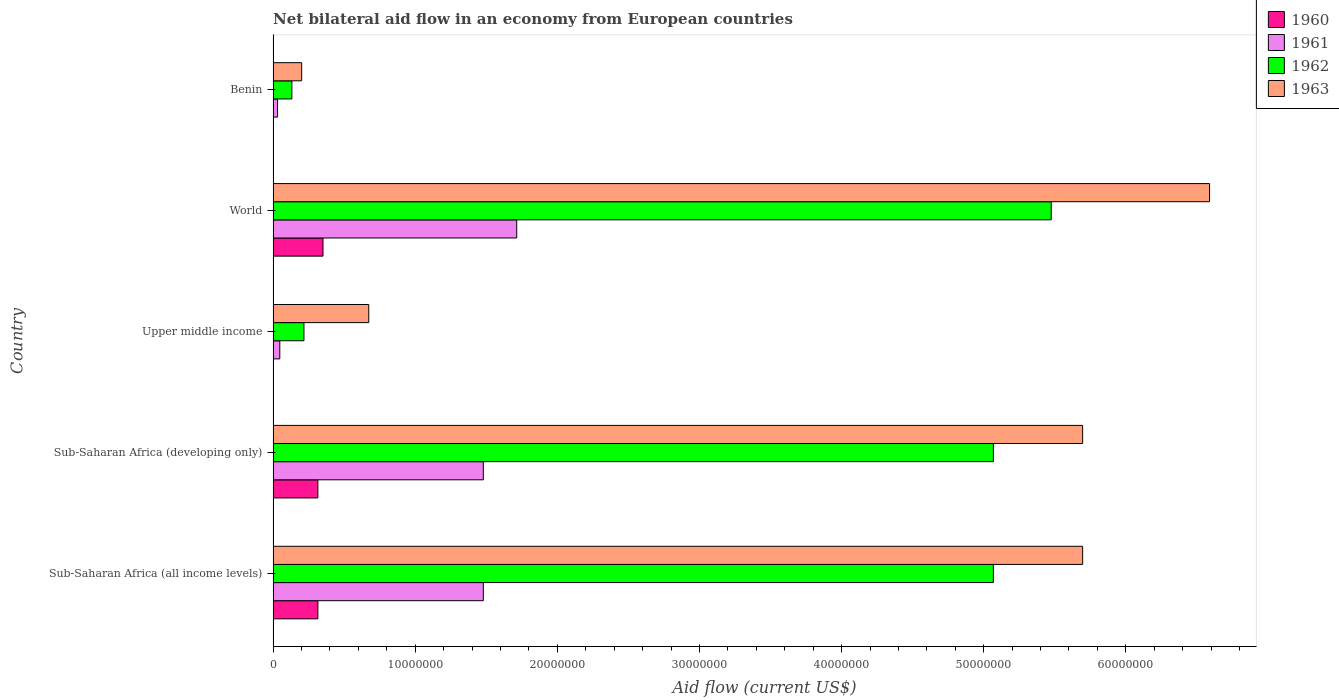How many different coloured bars are there?
Ensure brevity in your answer.  4. Are the number of bars per tick equal to the number of legend labels?
Provide a short and direct response. Yes. Are the number of bars on each tick of the Y-axis equal?
Keep it short and to the point. Yes. In how many cases, is the number of bars for a given country not equal to the number of legend labels?
Make the answer very short. 0. What is the net bilateral aid flow in 1963 in World?
Offer a terse response. 6.59e+07. Across all countries, what is the maximum net bilateral aid flow in 1961?
Your response must be concise. 1.71e+07. In which country was the net bilateral aid flow in 1960 maximum?
Offer a terse response. World. In which country was the net bilateral aid flow in 1963 minimum?
Your response must be concise. Benin. What is the total net bilateral aid flow in 1960 in the graph?
Ensure brevity in your answer.  9.83e+06. What is the difference between the net bilateral aid flow in 1961 in Sub-Saharan Africa (all income levels) and that in World?
Your answer should be compact. -2.35e+06. What is the difference between the net bilateral aid flow in 1961 in Sub-Saharan Africa (developing only) and the net bilateral aid flow in 1962 in World?
Make the answer very short. -4.00e+07. What is the average net bilateral aid flow in 1960 per country?
Offer a terse response. 1.97e+06. What is the difference between the net bilateral aid flow in 1963 and net bilateral aid flow in 1960 in Sub-Saharan Africa (all income levels)?
Give a very brief answer. 5.38e+07. In how many countries, is the net bilateral aid flow in 1960 greater than 44000000 US$?
Offer a very short reply. 0. What is the ratio of the net bilateral aid flow in 1962 in Upper middle income to that in World?
Keep it short and to the point. 0.04. Is the net bilateral aid flow in 1962 in Upper middle income less than that in World?
Make the answer very short. Yes. What is the difference between the highest and the second highest net bilateral aid flow in 1961?
Provide a succinct answer. 2.35e+06. What is the difference between the highest and the lowest net bilateral aid flow in 1961?
Keep it short and to the point. 1.68e+07. Is the sum of the net bilateral aid flow in 1962 in Sub-Saharan Africa (all income levels) and Upper middle income greater than the maximum net bilateral aid flow in 1960 across all countries?
Offer a terse response. Yes. Is it the case that in every country, the sum of the net bilateral aid flow in 1962 and net bilateral aid flow in 1963 is greater than the sum of net bilateral aid flow in 1960 and net bilateral aid flow in 1961?
Offer a terse response. No. What does the 1st bar from the top in Sub-Saharan Africa (all income levels) represents?
Give a very brief answer. 1963. Is it the case that in every country, the sum of the net bilateral aid flow in 1961 and net bilateral aid flow in 1962 is greater than the net bilateral aid flow in 1960?
Provide a succinct answer. Yes. Are all the bars in the graph horizontal?
Give a very brief answer. Yes. Are the values on the major ticks of X-axis written in scientific E-notation?
Offer a terse response. No. Does the graph contain grids?
Your answer should be very brief. No. How many legend labels are there?
Provide a succinct answer. 4. What is the title of the graph?
Provide a short and direct response. Net bilateral aid flow in an economy from European countries. Does "1997" appear as one of the legend labels in the graph?
Your response must be concise. No. What is the Aid flow (current US$) of 1960 in Sub-Saharan Africa (all income levels)?
Your response must be concise. 3.15e+06. What is the Aid flow (current US$) of 1961 in Sub-Saharan Africa (all income levels)?
Offer a very short reply. 1.48e+07. What is the Aid flow (current US$) of 1962 in Sub-Saharan Africa (all income levels)?
Provide a succinct answer. 5.07e+07. What is the Aid flow (current US$) of 1963 in Sub-Saharan Africa (all income levels)?
Your answer should be very brief. 5.70e+07. What is the Aid flow (current US$) of 1960 in Sub-Saharan Africa (developing only)?
Your answer should be compact. 3.15e+06. What is the Aid flow (current US$) in 1961 in Sub-Saharan Africa (developing only)?
Offer a terse response. 1.48e+07. What is the Aid flow (current US$) of 1962 in Sub-Saharan Africa (developing only)?
Give a very brief answer. 5.07e+07. What is the Aid flow (current US$) in 1963 in Sub-Saharan Africa (developing only)?
Provide a succinct answer. 5.70e+07. What is the Aid flow (current US$) in 1960 in Upper middle income?
Offer a very short reply. 10000. What is the Aid flow (current US$) of 1962 in Upper middle income?
Your answer should be very brief. 2.17e+06. What is the Aid flow (current US$) in 1963 in Upper middle income?
Offer a very short reply. 6.73e+06. What is the Aid flow (current US$) in 1960 in World?
Give a very brief answer. 3.51e+06. What is the Aid flow (current US$) of 1961 in World?
Provide a succinct answer. 1.71e+07. What is the Aid flow (current US$) of 1962 in World?
Give a very brief answer. 5.48e+07. What is the Aid flow (current US$) in 1963 in World?
Offer a terse response. 6.59e+07. What is the Aid flow (current US$) in 1962 in Benin?
Make the answer very short. 1.32e+06. What is the Aid flow (current US$) of 1963 in Benin?
Ensure brevity in your answer.  2.01e+06. Across all countries, what is the maximum Aid flow (current US$) of 1960?
Give a very brief answer. 3.51e+06. Across all countries, what is the maximum Aid flow (current US$) of 1961?
Your answer should be compact. 1.71e+07. Across all countries, what is the maximum Aid flow (current US$) of 1962?
Keep it short and to the point. 5.48e+07. Across all countries, what is the maximum Aid flow (current US$) in 1963?
Give a very brief answer. 6.59e+07. Across all countries, what is the minimum Aid flow (current US$) in 1962?
Your answer should be compact. 1.32e+06. Across all countries, what is the minimum Aid flow (current US$) in 1963?
Your response must be concise. 2.01e+06. What is the total Aid flow (current US$) of 1960 in the graph?
Your response must be concise. 9.83e+06. What is the total Aid flow (current US$) in 1961 in the graph?
Offer a terse response. 4.75e+07. What is the total Aid flow (current US$) of 1962 in the graph?
Give a very brief answer. 1.60e+08. What is the total Aid flow (current US$) of 1963 in the graph?
Ensure brevity in your answer.  1.89e+08. What is the difference between the Aid flow (current US$) of 1960 in Sub-Saharan Africa (all income levels) and that in Sub-Saharan Africa (developing only)?
Make the answer very short. 0. What is the difference between the Aid flow (current US$) of 1961 in Sub-Saharan Africa (all income levels) and that in Sub-Saharan Africa (developing only)?
Provide a succinct answer. 0. What is the difference between the Aid flow (current US$) in 1962 in Sub-Saharan Africa (all income levels) and that in Sub-Saharan Africa (developing only)?
Provide a short and direct response. 0. What is the difference between the Aid flow (current US$) of 1963 in Sub-Saharan Africa (all income levels) and that in Sub-Saharan Africa (developing only)?
Offer a very short reply. 0. What is the difference between the Aid flow (current US$) of 1960 in Sub-Saharan Africa (all income levels) and that in Upper middle income?
Offer a terse response. 3.14e+06. What is the difference between the Aid flow (current US$) in 1961 in Sub-Saharan Africa (all income levels) and that in Upper middle income?
Provide a short and direct response. 1.43e+07. What is the difference between the Aid flow (current US$) of 1962 in Sub-Saharan Africa (all income levels) and that in Upper middle income?
Provide a short and direct response. 4.85e+07. What is the difference between the Aid flow (current US$) of 1963 in Sub-Saharan Africa (all income levels) and that in Upper middle income?
Provide a succinct answer. 5.02e+07. What is the difference between the Aid flow (current US$) in 1960 in Sub-Saharan Africa (all income levels) and that in World?
Make the answer very short. -3.60e+05. What is the difference between the Aid flow (current US$) of 1961 in Sub-Saharan Africa (all income levels) and that in World?
Provide a short and direct response. -2.35e+06. What is the difference between the Aid flow (current US$) in 1962 in Sub-Saharan Africa (all income levels) and that in World?
Offer a very short reply. -4.07e+06. What is the difference between the Aid flow (current US$) in 1963 in Sub-Saharan Africa (all income levels) and that in World?
Give a very brief answer. -8.93e+06. What is the difference between the Aid flow (current US$) of 1960 in Sub-Saharan Africa (all income levels) and that in Benin?
Your answer should be very brief. 3.14e+06. What is the difference between the Aid flow (current US$) in 1961 in Sub-Saharan Africa (all income levels) and that in Benin?
Keep it short and to the point. 1.45e+07. What is the difference between the Aid flow (current US$) of 1962 in Sub-Saharan Africa (all income levels) and that in Benin?
Give a very brief answer. 4.94e+07. What is the difference between the Aid flow (current US$) of 1963 in Sub-Saharan Africa (all income levels) and that in Benin?
Offer a very short reply. 5.50e+07. What is the difference between the Aid flow (current US$) of 1960 in Sub-Saharan Africa (developing only) and that in Upper middle income?
Make the answer very short. 3.14e+06. What is the difference between the Aid flow (current US$) of 1961 in Sub-Saharan Africa (developing only) and that in Upper middle income?
Give a very brief answer. 1.43e+07. What is the difference between the Aid flow (current US$) of 1962 in Sub-Saharan Africa (developing only) and that in Upper middle income?
Offer a very short reply. 4.85e+07. What is the difference between the Aid flow (current US$) of 1963 in Sub-Saharan Africa (developing only) and that in Upper middle income?
Provide a succinct answer. 5.02e+07. What is the difference between the Aid flow (current US$) of 1960 in Sub-Saharan Africa (developing only) and that in World?
Your answer should be compact. -3.60e+05. What is the difference between the Aid flow (current US$) of 1961 in Sub-Saharan Africa (developing only) and that in World?
Give a very brief answer. -2.35e+06. What is the difference between the Aid flow (current US$) of 1962 in Sub-Saharan Africa (developing only) and that in World?
Your response must be concise. -4.07e+06. What is the difference between the Aid flow (current US$) of 1963 in Sub-Saharan Africa (developing only) and that in World?
Ensure brevity in your answer.  -8.93e+06. What is the difference between the Aid flow (current US$) of 1960 in Sub-Saharan Africa (developing only) and that in Benin?
Your answer should be compact. 3.14e+06. What is the difference between the Aid flow (current US$) of 1961 in Sub-Saharan Africa (developing only) and that in Benin?
Give a very brief answer. 1.45e+07. What is the difference between the Aid flow (current US$) of 1962 in Sub-Saharan Africa (developing only) and that in Benin?
Provide a short and direct response. 4.94e+07. What is the difference between the Aid flow (current US$) of 1963 in Sub-Saharan Africa (developing only) and that in Benin?
Provide a short and direct response. 5.50e+07. What is the difference between the Aid flow (current US$) of 1960 in Upper middle income and that in World?
Your answer should be compact. -3.50e+06. What is the difference between the Aid flow (current US$) of 1961 in Upper middle income and that in World?
Keep it short and to the point. -1.67e+07. What is the difference between the Aid flow (current US$) of 1962 in Upper middle income and that in World?
Ensure brevity in your answer.  -5.26e+07. What is the difference between the Aid flow (current US$) in 1963 in Upper middle income and that in World?
Ensure brevity in your answer.  -5.92e+07. What is the difference between the Aid flow (current US$) in 1960 in Upper middle income and that in Benin?
Keep it short and to the point. 0. What is the difference between the Aid flow (current US$) in 1961 in Upper middle income and that in Benin?
Offer a very short reply. 1.60e+05. What is the difference between the Aid flow (current US$) of 1962 in Upper middle income and that in Benin?
Keep it short and to the point. 8.50e+05. What is the difference between the Aid flow (current US$) of 1963 in Upper middle income and that in Benin?
Provide a short and direct response. 4.72e+06. What is the difference between the Aid flow (current US$) of 1960 in World and that in Benin?
Your response must be concise. 3.50e+06. What is the difference between the Aid flow (current US$) of 1961 in World and that in Benin?
Offer a terse response. 1.68e+07. What is the difference between the Aid flow (current US$) of 1962 in World and that in Benin?
Make the answer very short. 5.34e+07. What is the difference between the Aid flow (current US$) of 1963 in World and that in Benin?
Your answer should be compact. 6.39e+07. What is the difference between the Aid flow (current US$) in 1960 in Sub-Saharan Africa (all income levels) and the Aid flow (current US$) in 1961 in Sub-Saharan Africa (developing only)?
Make the answer very short. -1.16e+07. What is the difference between the Aid flow (current US$) in 1960 in Sub-Saharan Africa (all income levels) and the Aid flow (current US$) in 1962 in Sub-Saharan Africa (developing only)?
Ensure brevity in your answer.  -4.75e+07. What is the difference between the Aid flow (current US$) in 1960 in Sub-Saharan Africa (all income levels) and the Aid flow (current US$) in 1963 in Sub-Saharan Africa (developing only)?
Provide a succinct answer. -5.38e+07. What is the difference between the Aid flow (current US$) of 1961 in Sub-Saharan Africa (all income levels) and the Aid flow (current US$) of 1962 in Sub-Saharan Africa (developing only)?
Ensure brevity in your answer.  -3.59e+07. What is the difference between the Aid flow (current US$) in 1961 in Sub-Saharan Africa (all income levels) and the Aid flow (current US$) in 1963 in Sub-Saharan Africa (developing only)?
Offer a very short reply. -4.22e+07. What is the difference between the Aid flow (current US$) of 1962 in Sub-Saharan Africa (all income levels) and the Aid flow (current US$) of 1963 in Sub-Saharan Africa (developing only)?
Ensure brevity in your answer.  -6.28e+06. What is the difference between the Aid flow (current US$) in 1960 in Sub-Saharan Africa (all income levels) and the Aid flow (current US$) in 1961 in Upper middle income?
Ensure brevity in your answer.  2.68e+06. What is the difference between the Aid flow (current US$) in 1960 in Sub-Saharan Africa (all income levels) and the Aid flow (current US$) in 1962 in Upper middle income?
Ensure brevity in your answer.  9.80e+05. What is the difference between the Aid flow (current US$) of 1960 in Sub-Saharan Africa (all income levels) and the Aid flow (current US$) of 1963 in Upper middle income?
Provide a succinct answer. -3.58e+06. What is the difference between the Aid flow (current US$) in 1961 in Sub-Saharan Africa (all income levels) and the Aid flow (current US$) in 1962 in Upper middle income?
Provide a succinct answer. 1.26e+07. What is the difference between the Aid flow (current US$) in 1961 in Sub-Saharan Africa (all income levels) and the Aid flow (current US$) in 1963 in Upper middle income?
Provide a succinct answer. 8.06e+06. What is the difference between the Aid flow (current US$) of 1962 in Sub-Saharan Africa (all income levels) and the Aid flow (current US$) of 1963 in Upper middle income?
Provide a short and direct response. 4.40e+07. What is the difference between the Aid flow (current US$) in 1960 in Sub-Saharan Africa (all income levels) and the Aid flow (current US$) in 1961 in World?
Provide a succinct answer. -1.40e+07. What is the difference between the Aid flow (current US$) in 1960 in Sub-Saharan Africa (all income levels) and the Aid flow (current US$) in 1962 in World?
Your answer should be compact. -5.16e+07. What is the difference between the Aid flow (current US$) in 1960 in Sub-Saharan Africa (all income levels) and the Aid flow (current US$) in 1963 in World?
Provide a short and direct response. -6.27e+07. What is the difference between the Aid flow (current US$) of 1961 in Sub-Saharan Africa (all income levels) and the Aid flow (current US$) of 1962 in World?
Provide a succinct answer. -4.00e+07. What is the difference between the Aid flow (current US$) of 1961 in Sub-Saharan Africa (all income levels) and the Aid flow (current US$) of 1963 in World?
Offer a very short reply. -5.11e+07. What is the difference between the Aid flow (current US$) in 1962 in Sub-Saharan Africa (all income levels) and the Aid flow (current US$) in 1963 in World?
Provide a short and direct response. -1.52e+07. What is the difference between the Aid flow (current US$) in 1960 in Sub-Saharan Africa (all income levels) and the Aid flow (current US$) in 1961 in Benin?
Make the answer very short. 2.84e+06. What is the difference between the Aid flow (current US$) in 1960 in Sub-Saharan Africa (all income levels) and the Aid flow (current US$) in 1962 in Benin?
Your response must be concise. 1.83e+06. What is the difference between the Aid flow (current US$) in 1960 in Sub-Saharan Africa (all income levels) and the Aid flow (current US$) in 1963 in Benin?
Ensure brevity in your answer.  1.14e+06. What is the difference between the Aid flow (current US$) of 1961 in Sub-Saharan Africa (all income levels) and the Aid flow (current US$) of 1962 in Benin?
Provide a succinct answer. 1.35e+07. What is the difference between the Aid flow (current US$) of 1961 in Sub-Saharan Africa (all income levels) and the Aid flow (current US$) of 1963 in Benin?
Provide a short and direct response. 1.28e+07. What is the difference between the Aid flow (current US$) in 1962 in Sub-Saharan Africa (all income levels) and the Aid flow (current US$) in 1963 in Benin?
Offer a very short reply. 4.87e+07. What is the difference between the Aid flow (current US$) in 1960 in Sub-Saharan Africa (developing only) and the Aid flow (current US$) in 1961 in Upper middle income?
Your answer should be compact. 2.68e+06. What is the difference between the Aid flow (current US$) of 1960 in Sub-Saharan Africa (developing only) and the Aid flow (current US$) of 1962 in Upper middle income?
Keep it short and to the point. 9.80e+05. What is the difference between the Aid flow (current US$) of 1960 in Sub-Saharan Africa (developing only) and the Aid flow (current US$) of 1963 in Upper middle income?
Offer a very short reply. -3.58e+06. What is the difference between the Aid flow (current US$) of 1961 in Sub-Saharan Africa (developing only) and the Aid flow (current US$) of 1962 in Upper middle income?
Offer a very short reply. 1.26e+07. What is the difference between the Aid flow (current US$) in 1961 in Sub-Saharan Africa (developing only) and the Aid flow (current US$) in 1963 in Upper middle income?
Provide a short and direct response. 8.06e+06. What is the difference between the Aid flow (current US$) of 1962 in Sub-Saharan Africa (developing only) and the Aid flow (current US$) of 1963 in Upper middle income?
Provide a succinct answer. 4.40e+07. What is the difference between the Aid flow (current US$) of 1960 in Sub-Saharan Africa (developing only) and the Aid flow (current US$) of 1961 in World?
Keep it short and to the point. -1.40e+07. What is the difference between the Aid flow (current US$) of 1960 in Sub-Saharan Africa (developing only) and the Aid flow (current US$) of 1962 in World?
Your response must be concise. -5.16e+07. What is the difference between the Aid flow (current US$) in 1960 in Sub-Saharan Africa (developing only) and the Aid flow (current US$) in 1963 in World?
Your answer should be very brief. -6.27e+07. What is the difference between the Aid flow (current US$) in 1961 in Sub-Saharan Africa (developing only) and the Aid flow (current US$) in 1962 in World?
Offer a terse response. -4.00e+07. What is the difference between the Aid flow (current US$) in 1961 in Sub-Saharan Africa (developing only) and the Aid flow (current US$) in 1963 in World?
Offer a terse response. -5.11e+07. What is the difference between the Aid flow (current US$) in 1962 in Sub-Saharan Africa (developing only) and the Aid flow (current US$) in 1963 in World?
Offer a very short reply. -1.52e+07. What is the difference between the Aid flow (current US$) of 1960 in Sub-Saharan Africa (developing only) and the Aid flow (current US$) of 1961 in Benin?
Provide a short and direct response. 2.84e+06. What is the difference between the Aid flow (current US$) in 1960 in Sub-Saharan Africa (developing only) and the Aid flow (current US$) in 1962 in Benin?
Your answer should be very brief. 1.83e+06. What is the difference between the Aid flow (current US$) in 1960 in Sub-Saharan Africa (developing only) and the Aid flow (current US$) in 1963 in Benin?
Give a very brief answer. 1.14e+06. What is the difference between the Aid flow (current US$) of 1961 in Sub-Saharan Africa (developing only) and the Aid flow (current US$) of 1962 in Benin?
Offer a terse response. 1.35e+07. What is the difference between the Aid flow (current US$) of 1961 in Sub-Saharan Africa (developing only) and the Aid flow (current US$) of 1963 in Benin?
Ensure brevity in your answer.  1.28e+07. What is the difference between the Aid flow (current US$) of 1962 in Sub-Saharan Africa (developing only) and the Aid flow (current US$) of 1963 in Benin?
Make the answer very short. 4.87e+07. What is the difference between the Aid flow (current US$) in 1960 in Upper middle income and the Aid flow (current US$) in 1961 in World?
Give a very brief answer. -1.71e+07. What is the difference between the Aid flow (current US$) in 1960 in Upper middle income and the Aid flow (current US$) in 1962 in World?
Your answer should be very brief. -5.47e+07. What is the difference between the Aid flow (current US$) of 1960 in Upper middle income and the Aid flow (current US$) of 1963 in World?
Offer a terse response. -6.59e+07. What is the difference between the Aid flow (current US$) of 1961 in Upper middle income and the Aid flow (current US$) of 1962 in World?
Your answer should be very brief. -5.43e+07. What is the difference between the Aid flow (current US$) in 1961 in Upper middle income and the Aid flow (current US$) in 1963 in World?
Ensure brevity in your answer.  -6.54e+07. What is the difference between the Aid flow (current US$) in 1962 in Upper middle income and the Aid flow (current US$) in 1963 in World?
Keep it short and to the point. -6.37e+07. What is the difference between the Aid flow (current US$) of 1960 in Upper middle income and the Aid flow (current US$) of 1962 in Benin?
Your answer should be very brief. -1.31e+06. What is the difference between the Aid flow (current US$) of 1961 in Upper middle income and the Aid flow (current US$) of 1962 in Benin?
Provide a succinct answer. -8.50e+05. What is the difference between the Aid flow (current US$) in 1961 in Upper middle income and the Aid flow (current US$) in 1963 in Benin?
Make the answer very short. -1.54e+06. What is the difference between the Aid flow (current US$) in 1960 in World and the Aid flow (current US$) in 1961 in Benin?
Keep it short and to the point. 3.20e+06. What is the difference between the Aid flow (current US$) of 1960 in World and the Aid flow (current US$) of 1962 in Benin?
Keep it short and to the point. 2.19e+06. What is the difference between the Aid flow (current US$) of 1960 in World and the Aid flow (current US$) of 1963 in Benin?
Your response must be concise. 1.50e+06. What is the difference between the Aid flow (current US$) in 1961 in World and the Aid flow (current US$) in 1962 in Benin?
Offer a very short reply. 1.58e+07. What is the difference between the Aid flow (current US$) of 1961 in World and the Aid flow (current US$) of 1963 in Benin?
Make the answer very short. 1.51e+07. What is the difference between the Aid flow (current US$) in 1962 in World and the Aid flow (current US$) in 1963 in Benin?
Provide a short and direct response. 5.27e+07. What is the average Aid flow (current US$) of 1960 per country?
Ensure brevity in your answer.  1.97e+06. What is the average Aid flow (current US$) of 1961 per country?
Provide a succinct answer. 9.50e+06. What is the average Aid flow (current US$) in 1962 per country?
Provide a short and direct response. 3.19e+07. What is the average Aid flow (current US$) in 1963 per country?
Provide a succinct answer. 3.77e+07. What is the difference between the Aid flow (current US$) in 1960 and Aid flow (current US$) in 1961 in Sub-Saharan Africa (all income levels)?
Offer a terse response. -1.16e+07. What is the difference between the Aid flow (current US$) in 1960 and Aid flow (current US$) in 1962 in Sub-Saharan Africa (all income levels)?
Your response must be concise. -4.75e+07. What is the difference between the Aid flow (current US$) of 1960 and Aid flow (current US$) of 1963 in Sub-Saharan Africa (all income levels)?
Provide a succinct answer. -5.38e+07. What is the difference between the Aid flow (current US$) in 1961 and Aid flow (current US$) in 1962 in Sub-Saharan Africa (all income levels)?
Provide a short and direct response. -3.59e+07. What is the difference between the Aid flow (current US$) in 1961 and Aid flow (current US$) in 1963 in Sub-Saharan Africa (all income levels)?
Give a very brief answer. -4.22e+07. What is the difference between the Aid flow (current US$) in 1962 and Aid flow (current US$) in 1963 in Sub-Saharan Africa (all income levels)?
Provide a succinct answer. -6.28e+06. What is the difference between the Aid flow (current US$) of 1960 and Aid flow (current US$) of 1961 in Sub-Saharan Africa (developing only)?
Your answer should be very brief. -1.16e+07. What is the difference between the Aid flow (current US$) of 1960 and Aid flow (current US$) of 1962 in Sub-Saharan Africa (developing only)?
Your response must be concise. -4.75e+07. What is the difference between the Aid flow (current US$) in 1960 and Aid flow (current US$) in 1963 in Sub-Saharan Africa (developing only)?
Your answer should be very brief. -5.38e+07. What is the difference between the Aid flow (current US$) in 1961 and Aid flow (current US$) in 1962 in Sub-Saharan Africa (developing only)?
Provide a short and direct response. -3.59e+07. What is the difference between the Aid flow (current US$) of 1961 and Aid flow (current US$) of 1963 in Sub-Saharan Africa (developing only)?
Offer a terse response. -4.22e+07. What is the difference between the Aid flow (current US$) of 1962 and Aid flow (current US$) of 1963 in Sub-Saharan Africa (developing only)?
Provide a succinct answer. -6.28e+06. What is the difference between the Aid flow (current US$) of 1960 and Aid flow (current US$) of 1961 in Upper middle income?
Provide a succinct answer. -4.60e+05. What is the difference between the Aid flow (current US$) of 1960 and Aid flow (current US$) of 1962 in Upper middle income?
Ensure brevity in your answer.  -2.16e+06. What is the difference between the Aid flow (current US$) in 1960 and Aid flow (current US$) in 1963 in Upper middle income?
Your response must be concise. -6.72e+06. What is the difference between the Aid flow (current US$) in 1961 and Aid flow (current US$) in 1962 in Upper middle income?
Provide a succinct answer. -1.70e+06. What is the difference between the Aid flow (current US$) of 1961 and Aid flow (current US$) of 1963 in Upper middle income?
Your answer should be compact. -6.26e+06. What is the difference between the Aid flow (current US$) of 1962 and Aid flow (current US$) of 1963 in Upper middle income?
Ensure brevity in your answer.  -4.56e+06. What is the difference between the Aid flow (current US$) in 1960 and Aid flow (current US$) in 1961 in World?
Your answer should be compact. -1.36e+07. What is the difference between the Aid flow (current US$) of 1960 and Aid flow (current US$) of 1962 in World?
Provide a short and direct response. -5.12e+07. What is the difference between the Aid flow (current US$) in 1960 and Aid flow (current US$) in 1963 in World?
Offer a terse response. -6.24e+07. What is the difference between the Aid flow (current US$) in 1961 and Aid flow (current US$) in 1962 in World?
Make the answer very short. -3.76e+07. What is the difference between the Aid flow (current US$) of 1961 and Aid flow (current US$) of 1963 in World?
Make the answer very short. -4.88e+07. What is the difference between the Aid flow (current US$) of 1962 and Aid flow (current US$) of 1963 in World?
Your response must be concise. -1.11e+07. What is the difference between the Aid flow (current US$) in 1960 and Aid flow (current US$) in 1962 in Benin?
Provide a short and direct response. -1.31e+06. What is the difference between the Aid flow (current US$) in 1960 and Aid flow (current US$) in 1963 in Benin?
Keep it short and to the point. -2.00e+06. What is the difference between the Aid flow (current US$) in 1961 and Aid flow (current US$) in 1962 in Benin?
Make the answer very short. -1.01e+06. What is the difference between the Aid flow (current US$) of 1961 and Aid flow (current US$) of 1963 in Benin?
Offer a terse response. -1.70e+06. What is the difference between the Aid flow (current US$) in 1962 and Aid flow (current US$) in 1963 in Benin?
Offer a terse response. -6.90e+05. What is the ratio of the Aid flow (current US$) in 1960 in Sub-Saharan Africa (all income levels) to that in Sub-Saharan Africa (developing only)?
Keep it short and to the point. 1. What is the ratio of the Aid flow (current US$) in 1961 in Sub-Saharan Africa (all income levels) to that in Sub-Saharan Africa (developing only)?
Provide a short and direct response. 1. What is the ratio of the Aid flow (current US$) in 1962 in Sub-Saharan Africa (all income levels) to that in Sub-Saharan Africa (developing only)?
Your answer should be very brief. 1. What is the ratio of the Aid flow (current US$) in 1960 in Sub-Saharan Africa (all income levels) to that in Upper middle income?
Your answer should be compact. 315. What is the ratio of the Aid flow (current US$) in 1961 in Sub-Saharan Africa (all income levels) to that in Upper middle income?
Give a very brief answer. 31.47. What is the ratio of the Aid flow (current US$) of 1962 in Sub-Saharan Africa (all income levels) to that in Upper middle income?
Your response must be concise. 23.35. What is the ratio of the Aid flow (current US$) in 1963 in Sub-Saharan Africa (all income levels) to that in Upper middle income?
Give a very brief answer. 8.46. What is the ratio of the Aid flow (current US$) of 1960 in Sub-Saharan Africa (all income levels) to that in World?
Your response must be concise. 0.9. What is the ratio of the Aid flow (current US$) in 1961 in Sub-Saharan Africa (all income levels) to that in World?
Ensure brevity in your answer.  0.86. What is the ratio of the Aid flow (current US$) in 1962 in Sub-Saharan Africa (all income levels) to that in World?
Ensure brevity in your answer.  0.93. What is the ratio of the Aid flow (current US$) in 1963 in Sub-Saharan Africa (all income levels) to that in World?
Give a very brief answer. 0.86. What is the ratio of the Aid flow (current US$) of 1960 in Sub-Saharan Africa (all income levels) to that in Benin?
Make the answer very short. 315. What is the ratio of the Aid flow (current US$) in 1961 in Sub-Saharan Africa (all income levels) to that in Benin?
Your answer should be compact. 47.71. What is the ratio of the Aid flow (current US$) in 1962 in Sub-Saharan Africa (all income levels) to that in Benin?
Your answer should be very brief. 38.39. What is the ratio of the Aid flow (current US$) of 1963 in Sub-Saharan Africa (all income levels) to that in Benin?
Provide a short and direct response. 28.34. What is the ratio of the Aid flow (current US$) in 1960 in Sub-Saharan Africa (developing only) to that in Upper middle income?
Offer a terse response. 315. What is the ratio of the Aid flow (current US$) of 1961 in Sub-Saharan Africa (developing only) to that in Upper middle income?
Your response must be concise. 31.47. What is the ratio of the Aid flow (current US$) of 1962 in Sub-Saharan Africa (developing only) to that in Upper middle income?
Ensure brevity in your answer.  23.35. What is the ratio of the Aid flow (current US$) of 1963 in Sub-Saharan Africa (developing only) to that in Upper middle income?
Provide a succinct answer. 8.46. What is the ratio of the Aid flow (current US$) of 1960 in Sub-Saharan Africa (developing only) to that in World?
Your response must be concise. 0.9. What is the ratio of the Aid flow (current US$) of 1961 in Sub-Saharan Africa (developing only) to that in World?
Ensure brevity in your answer.  0.86. What is the ratio of the Aid flow (current US$) in 1962 in Sub-Saharan Africa (developing only) to that in World?
Provide a succinct answer. 0.93. What is the ratio of the Aid flow (current US$) of 1963 in Sub-Saharan Africa (developing only) to that in World?
Provide a succinct answer. 0.86. What is the ratio of the Aid flow (current US$) in 1960 in Sub-Saharan Africa (developing only) to that in Benin?
Provide a short and direct response. 315. What is the ratio of the Aid flow (current US$) in 1961 in Sub-Saharan Africa (developing only) to that in Benin?
Your answer should be compact. 47.71. What is the ratio of the Aid flow (current US$) in 1962 in Sub-Saharan Africa (developing only) to that in Benin?
Provide a short and direct response. 38.39. What is the ratio of the Aid flow (current US$) in 1963 in Sub-Saharan Africa (developing only) to that in Benin?
Ensure brevity in your answer.  28.34. What is the ratio of the Aid flow (current US$) of 1960 in Upper middle income to that in World?
Keep it short and to the point. 0. What is the ratio of the Aid flow (current US$) of 1961 in Upper middle income to that in World?
Offer a very short reply. 0.03. What is the ratio of the Aid flow (current US$) of 1962 in Upper middle income to that in World?
Offer a terse response. 0.04. What is the ratio of the Aid flow (current US$) in 1963 in Upper middle income to that in World?
Ensure brevity in your answer.  0.1. What is the ratio of the Aid flow (current US$) in 1960 in Upper middle income to that in Benin?
Keep it short and to the point. 1. What is the ratio of the Aid flow (current US$) of 1961 in Upper middle income to that in Benin?
Your response must be concise. 1.52. What is the ratio of the Aid flow (current US$) in 1962 in Upper middle income to that in Benin?
Ensure brevity in your answer.  1.64. What is the ratio of the Aid flow (current US$) in 1963 in Upper middle income to that in Benin?
Make the answer very short. 3.35. What is the ratio of the Aid flow (current US$) of 1960 in World to that in Benin?
Make the answer very short. 351. What is the ratio of the Aid flow (current US$) in 1961 in World to that in Benin?
Provide a succinct answer. 55.29. What is the ratio of the Aid flow (current US$) in 1962 in World to that in Benin?
Your response must be concise. 41.48. What is the ratio of the Aid flow (current US$) in 1963 in World to that in Benin?
Offer a terse response. 32.78. What is the difference between the highest and the second highest Aid flow (current US$) in 1961?
Ensure brevity in your answer.  2.35e+06. What is the difference between the highest and the second highest Aid flow (current US$) in 1962?
Offer a very short reply. 4.07e+06. What is the difference between the highest and the second highest Aid flow (current US$) of 1963?
Offer a terse response. 8.93e+06. What is the difference between the highest and the lowest Aid flow (current US$) in 1960?
Your response must be concise. 3.50e+06. What is the difference between the highest and the lowest Aid flow (current US$) in 1961?
Offer a terse response. 1.68e+07. What is the difference between the highest and the lowest Aid flow (current US$) of 1962?
Provide a short and direct response. 5.34e+07. What is the difference between the highest and the lowest Aid flow (current US$) of 1963?
Your response must be concise. 6.39e+07. 